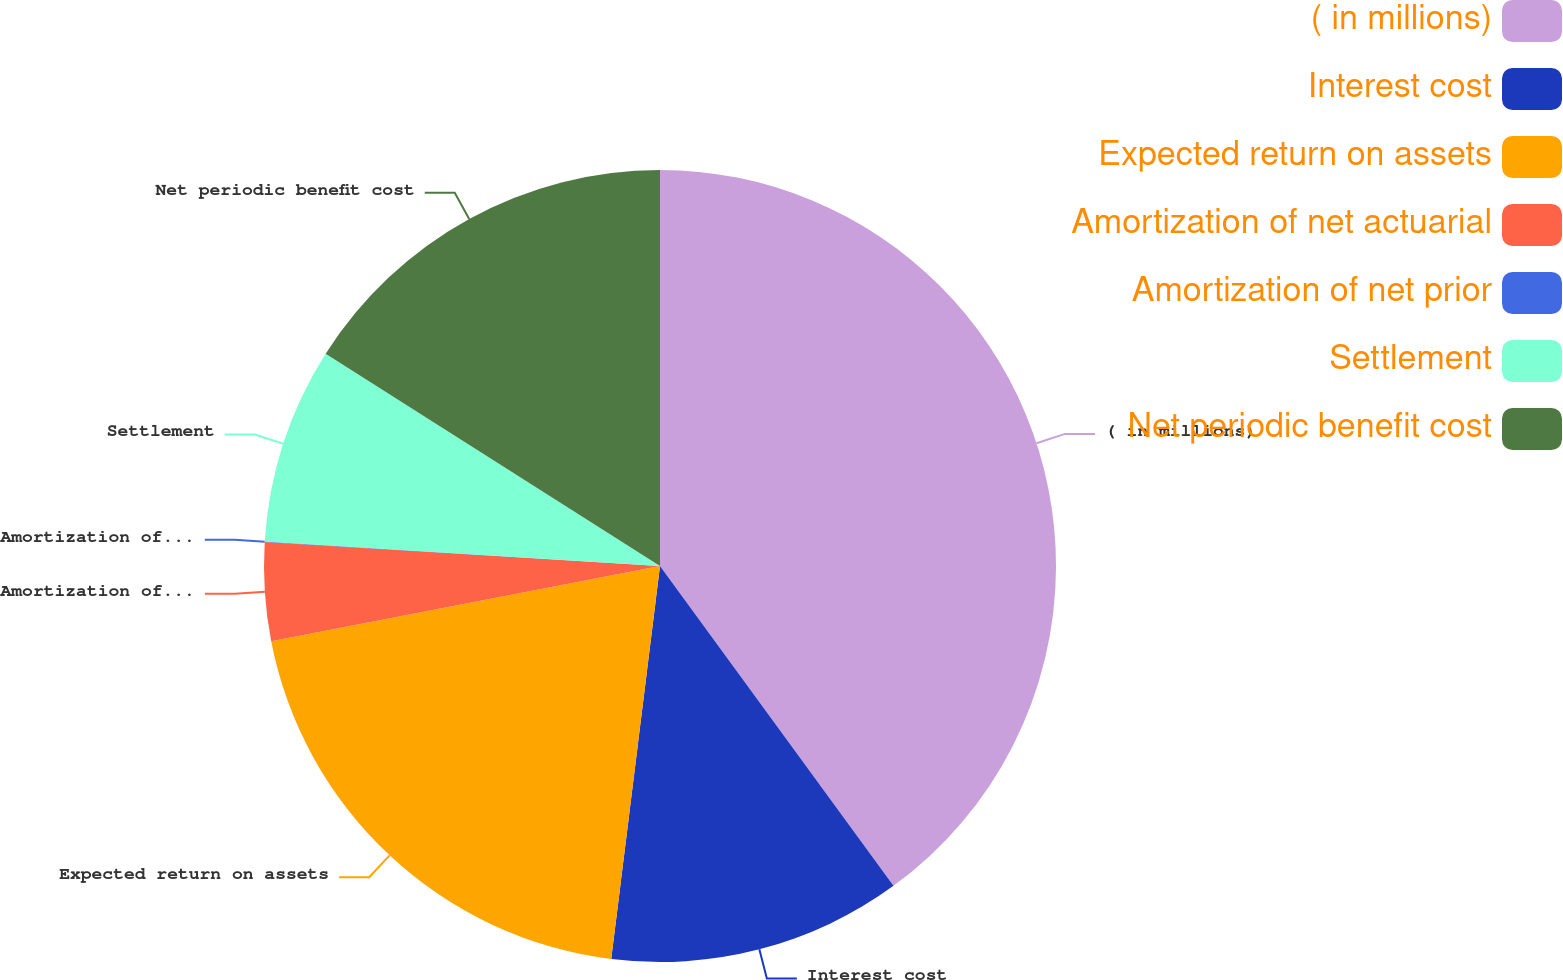<chart> <loc_0><loc_0><loc_500><loc_500><pie_chart><fcel>( in millions)<fcel>Interest cost<fcel>Expected return on assets<fcel>Amortization of net actuarial<fcel>Amortization of net prior<fcel>Settlement<fcel>Net periodic benefit cost<nl><fcel>39.96%<fcel>12.0%<fcel>19.99%<fcel>4.01%<fcel>0.02%<fcel>8.01%<fcel>16.0%<nl></chart> 